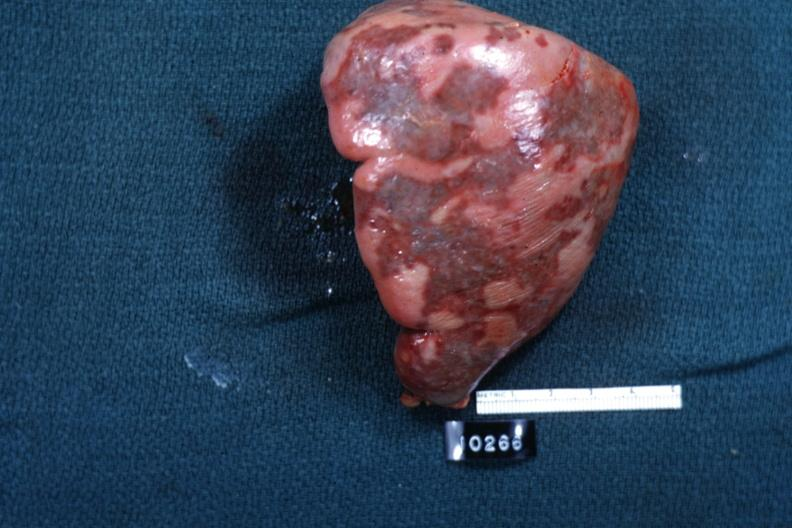does nodule show external view of spleen with multiple recent infarcts cut surface is slide?
Answer the question using a single word or phrase. No 